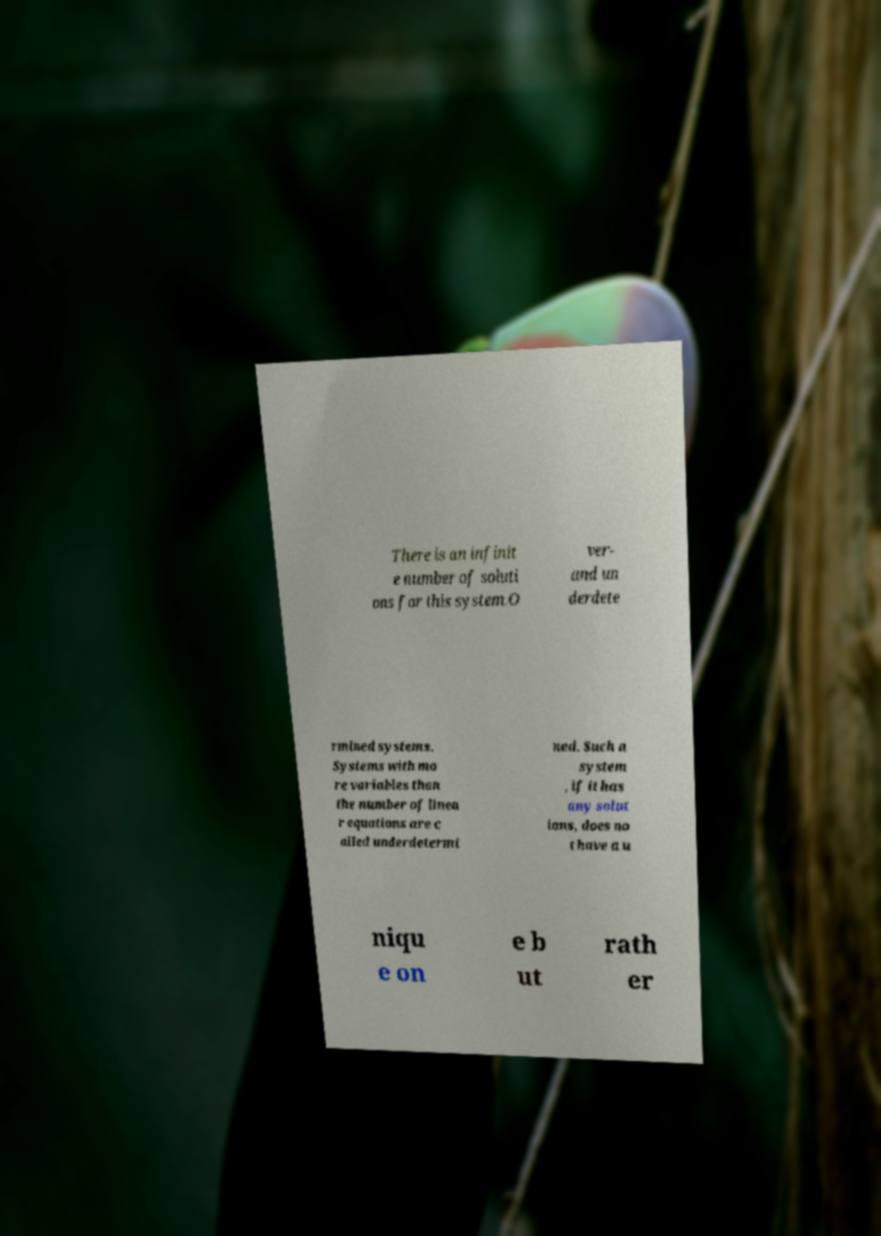Please identify and transcribe the text found in this image. There is an infinit e number of soluti ons for this system.O ver- and un derdete rmined systems. Systems with mo re variables than the number of linea r equations are c alled underdetermi ned. Such a system , if it has any solut ions, does no t have a u niqu e on e b ut rath er 